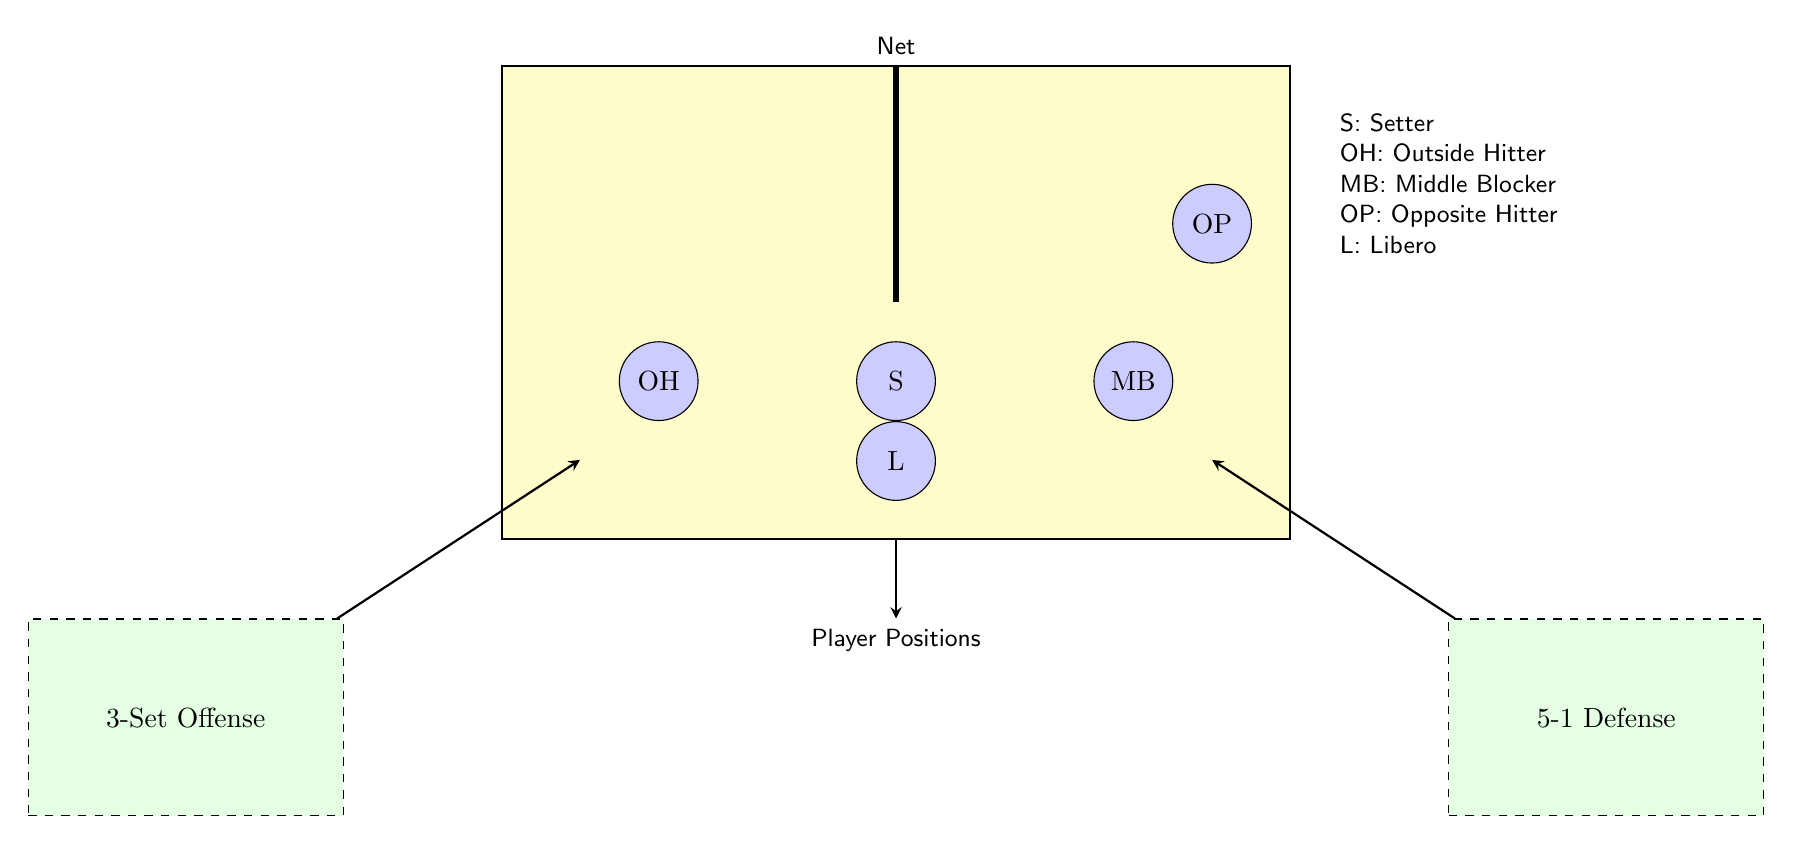What is the role of player "S"? The player labeled "S" corresponds to the Setter position in volleyball. This position is crucial as the Setter is typically responsible for orchestrating the attack.
Answer: Setter How many players are depicted in the diagram? The diagram includes five distinct player positions labeled as S, OH, MB, OP, and L. Thus, there are a total of five players illustrated.
Answer: 5 Which player is positioned as the Outside Hitter? In the diagram, the player positioned as the Outside Hitter is labeled "OH". This player is located on the left side of the court in the offensive formation.
Answer: OH What does the 3-Set Offense formation imply? The 3-Set Offense indicates a specific attacking strategy where three front-row players are involved in the offensive play. This formation is meant to maximize offensive options against the defense.
Answer: Offensive strategy In what region of the court is the Libero positioned? The Libero is shown at the bottom center of the court, indicating their position is typically towards the back row, where they focus on defensive plays and receive serves.
Answer: Bottom center What are the two formations represented in the diagram? The diagram represents two formations labeled as "3-Set Offense" and "5-1 Defense." These show the strategies for both attacking and defending during gameplay.
Answer: 3-Set Offense and 5-1 Defense Which player is closest to the net? The player labeled as "OP," the Opposite Hitter, is positioned above the setter, making them closest to the net when the court is divided into offensive and defensive setups.
Answer: OP What position does "MB" represent? The player labeled "MB" stands for Middle Blocker, a position critical for defense as they aim to block opposing attacks and play a key role in the middle of the net.
Answer: Middle Blocker What direction do the arrows indicate in the diagram? The arrows in the diagram point from the formations towards respective player positions, illustrating player movements and the strategies from offensive and defensive formations.
Answer: Player movements 